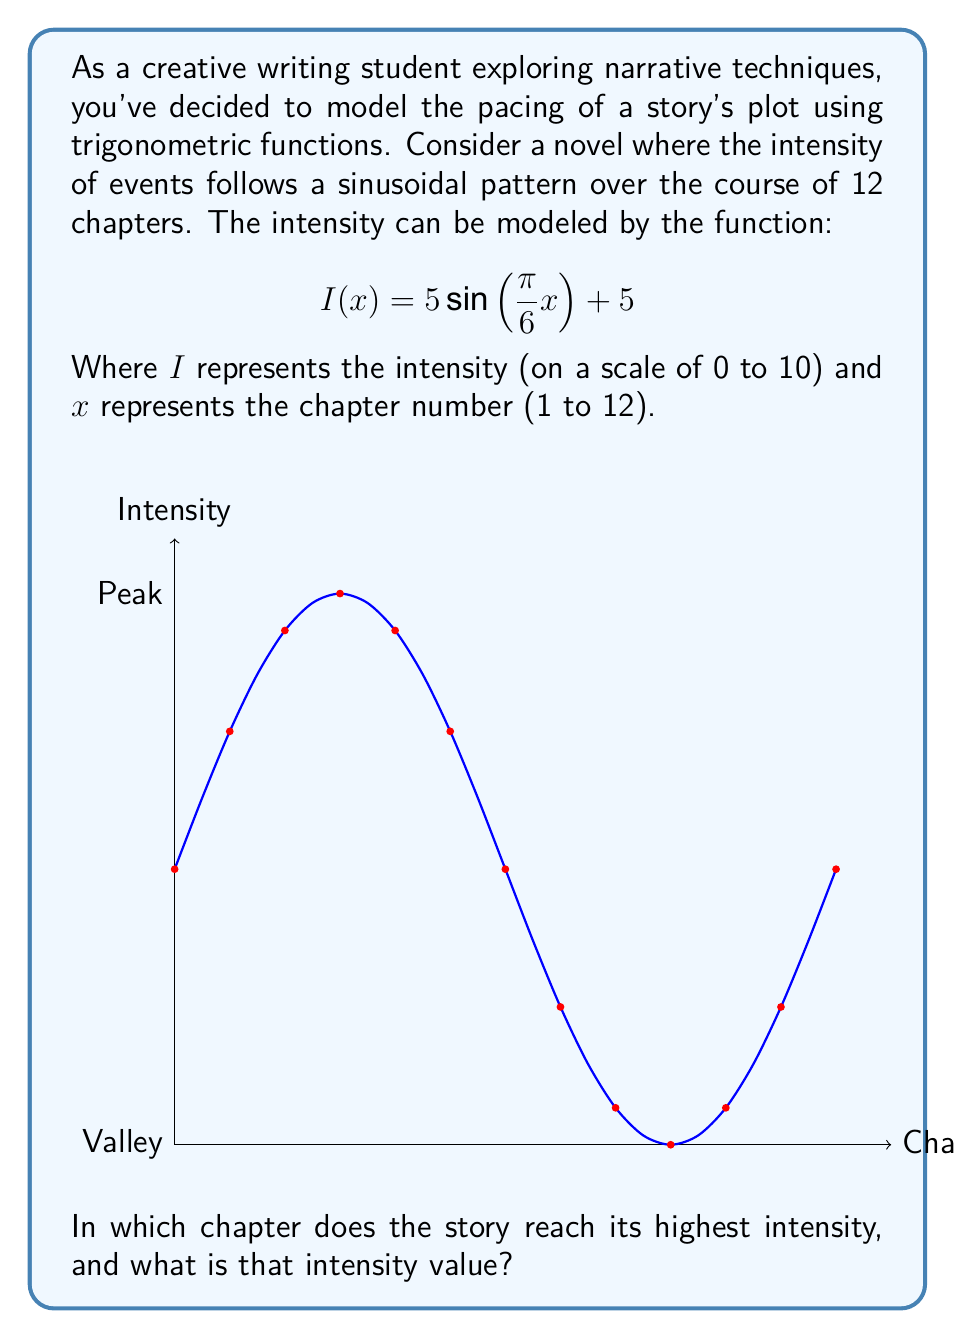Could you help me with this problem? To solve this problem, we need to follow these steps:

1) The sine function reaches its maximum value when its argument is $\frac{\pi}{2}$ (or 90°). So we need to find $x$ where:

   $$\frac{\pi}{6}x = \frac{\pi}{2}$$

2) Solving for $x$:
   
   $$x = \frac{\pi/2}{\pi/6} = 3$$

3) This means the intensity peaks at chapter 3 and every 6 chapters after that (due to the periodicity of sine). In the given range of 1 to 12 chapters, the peaks occur at chapters 3 and 9.

4) To find the intensity value at these peaks, we substitute $x = 3$ (or 9) into the original function:

   $$I(3) = 5\sin(\frac{\pi}{6} \cdot 3) + 5 = 5\sin(\frac{\pi}{2}) + 5 = 5 \cdot 1 + 5 = 10$$

5) Therefore, the maximum intensity is 10, occurring at chapters 3 and 9.

6) Since we're asked for a single chapter, we'll choose the first occurrence, which is chapter 3.
Answer: Chapter 3, with intensity 10 